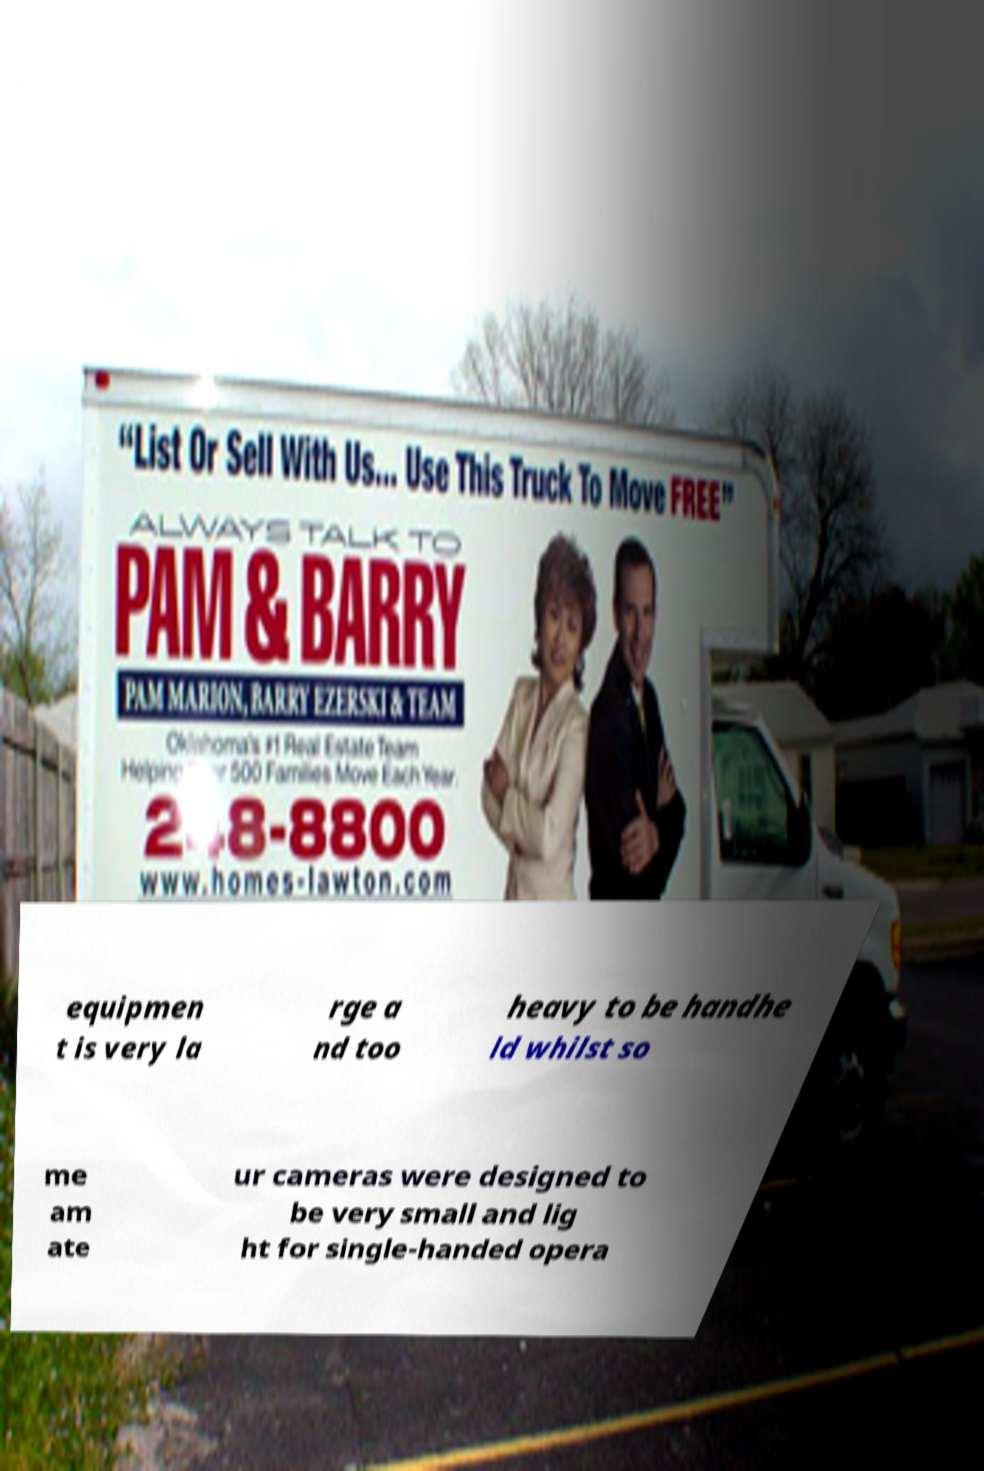What messages or text are displayed in this image? I need them in a readable, typed format. equipmen t is very la rge a nd too heavy to be handhe ld whilst so me am ate ur cameras were designed to be very small and lig ht for single-handed opera 